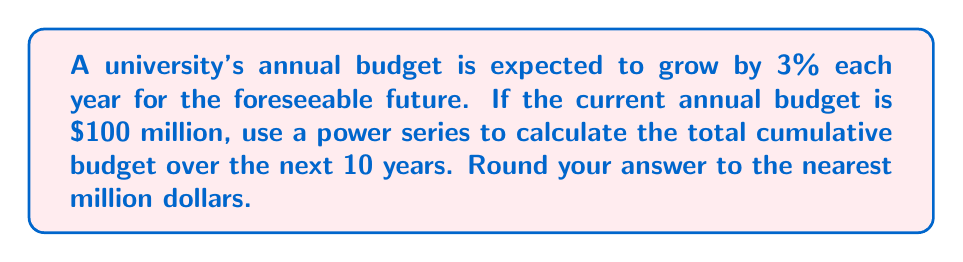Can you solve this math problem? Let's approach this step-by-step:

1) First, let's define our series. Let $a_n$ be the budget for year $n$, where $n = 0$ is the current year.

   $a_0 = 100$ million
   $a_n = a_0 \cdot (1.03)^n$ for $n \geq 1$

2) The sum we're looking for is:

   $S = \sum_{n=0}^{10} a_n = \sum_{n=0}^{10} 100 \cdot (1.03)^n$

3) This is a geometric series with first term $a = 100$ and common ratio $r = 1.03$. The sum of a geometric series is given by:

   $S_n = a \cdot \frac{1-r^{n+1}}{1-r}$ where $n = 10$ in our case.

4) Plugging in our values:

   $S = 100 \cdot \frac{1-(1.03)^{11}}{1-1.03}$

5) Simplify:

   $S = 100 \cdot \frac{1-1.3439}{-0.03} = 100 \cdot \frac{-0.3439}{-0.03}$

6) Calculate:

   $S = 100 \cdot 11.4633 = 1146.33$ million

7) Rounding to the nearest million:

   $S \approx 1146$ million dollars
Answer: $1146 million 